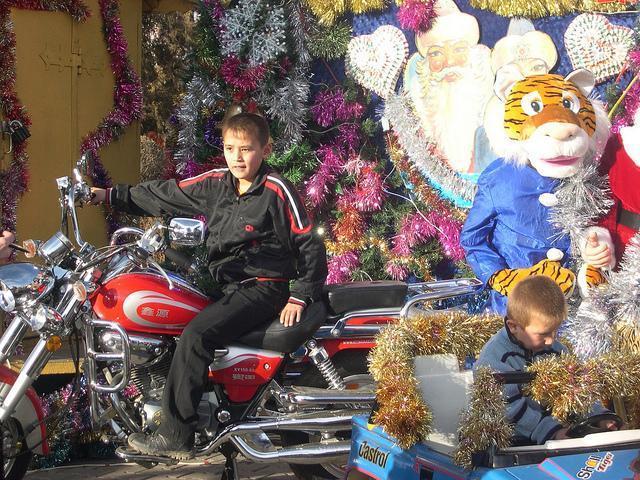How many people can be seen?
Give a very brief answer. 3. How many birds are standing on the boat?
Give a very brief answer. 0. 